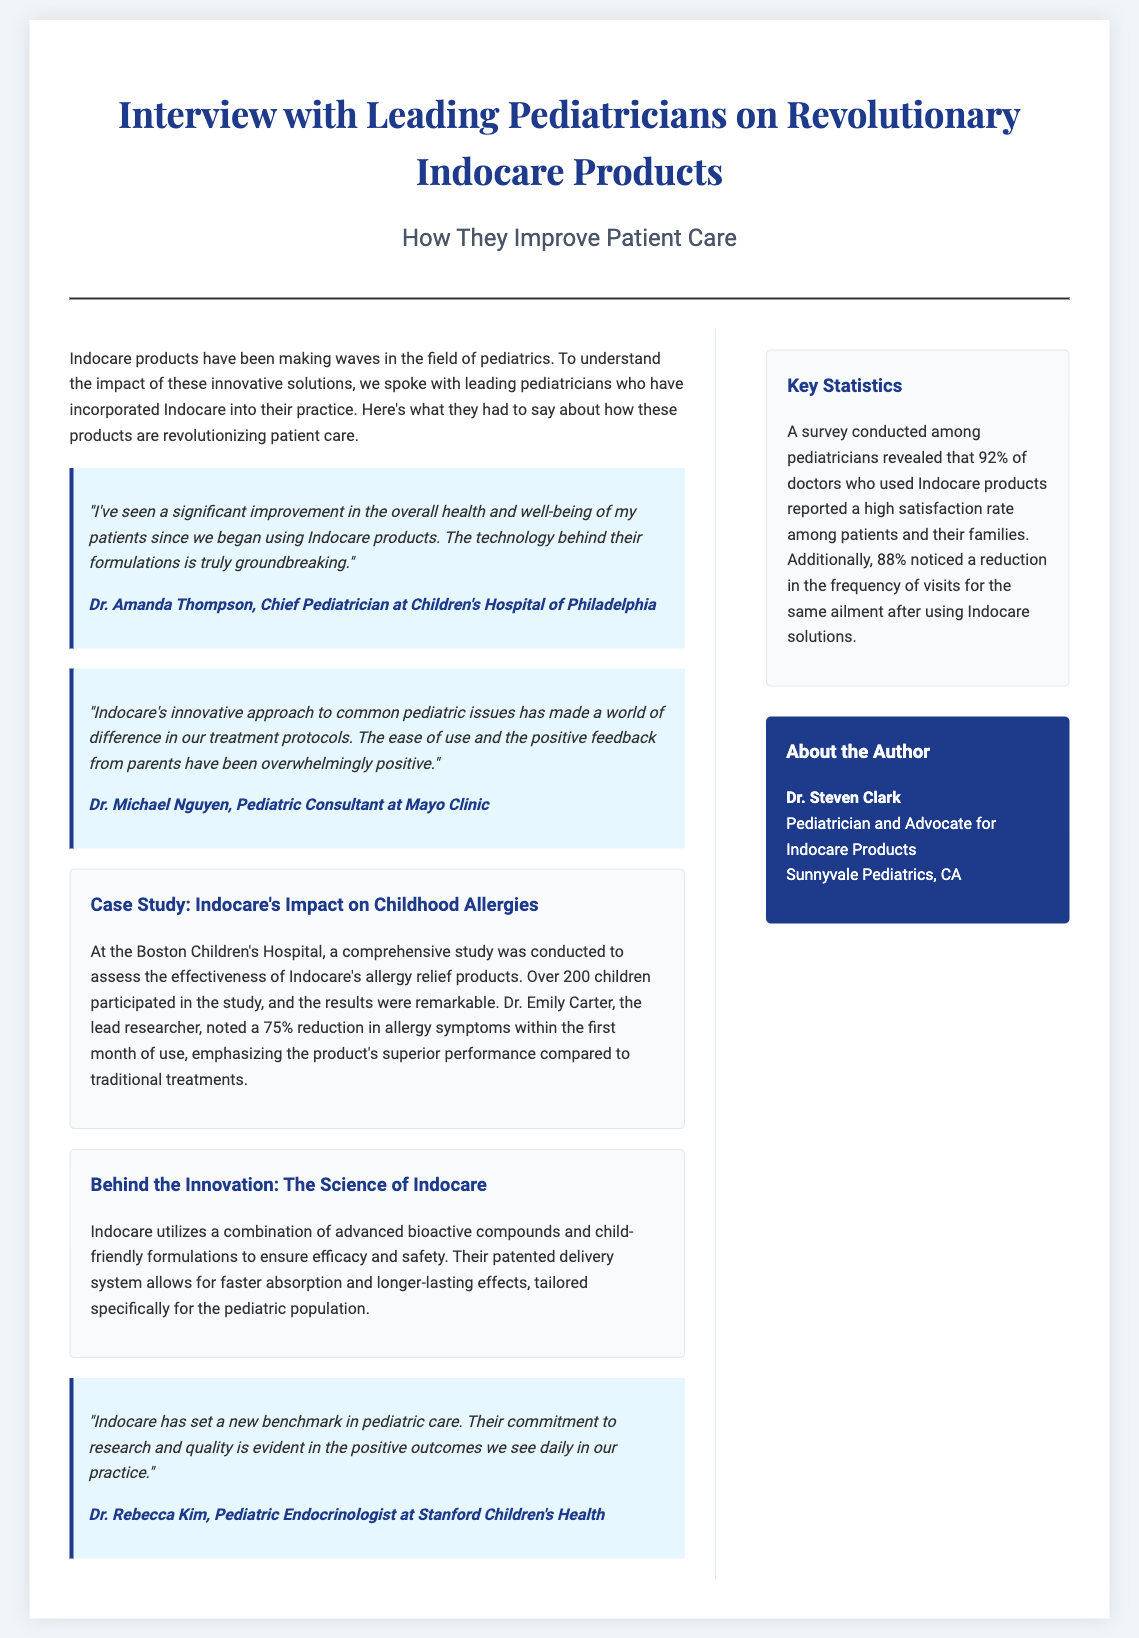What is the primary focus of the article? The article discusses the impact of Indocare products on pediatric care through interviews with leading pediatricians.
Answer: Indocare products Who is the Chief Pediatrician mentioned in the document? Dr. Amanda Thompson is identified as the Chief Pediatrician at Children's Hospital of Philadelphia.
Answer: Dr. Amanda Thompson What percentage of doctors reported a high satisfaction rate with Indocare products? According to the survey, 92% of doctors reported a high satisfaction rate among patients and their families.
Answer: 92% What is the observed reduction in allergy symptoms noted in the case study? The case study at Boston Children's Hospital reported a 75% reduction in allergy symptoms within the first month of use.
Answer: 75% Which pediatrician highlighted the commitment to research and quality of Indocare? Dr. Rebecca Kim emphasized Indocare's commitment to research and quality in her quote.
Answer: Dr. Rebecca Kim What type of products does Indocare specialize in according to the document? Indocare specializes in innovative solutions for common pediatric issues, particularly allergy relief products.
Answer: Allergy relief products How many children participated in the case study on Indocare's allergy products? Over 200 children participated in the study conducted at Boston Children's Hospital.
Answer: 200 What do the statistics indicate about follow-up visits after using Indocare solutions? The statistics indicate that 88% of pediatricians noticed a reduction in the frequency of visits for the same ailment after using Indocare solutions.
Answer: 88% 